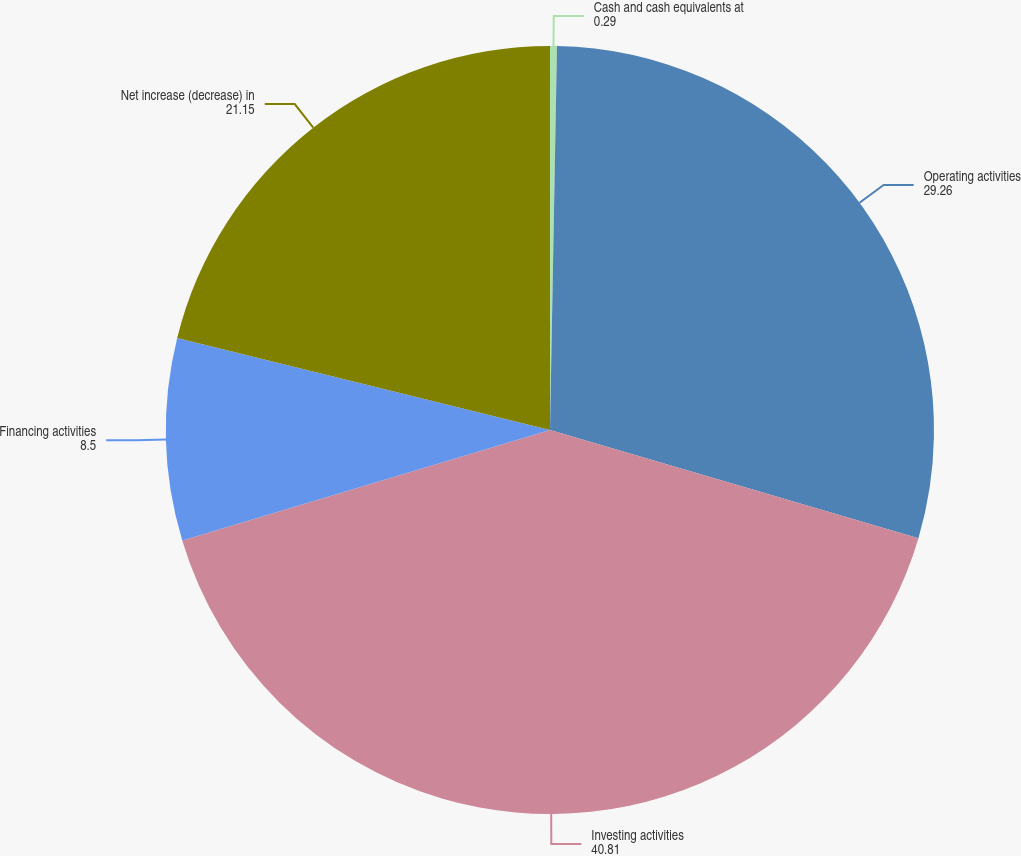Convert chart to OTSL. <chart><loc_0><loc_0><loc_500><loc_500><pie_chart><fcel>Cash and cash equivalents at<fcel>Operating activities<fcel>Investing activities<fcel>Financing activities<fcel>Net increase (decrease) in<nl><fcel>0.29%<fcel>29.26%<fcel>40.81%<fcel>8.5%<fcel>21.15%<nl></chart> 